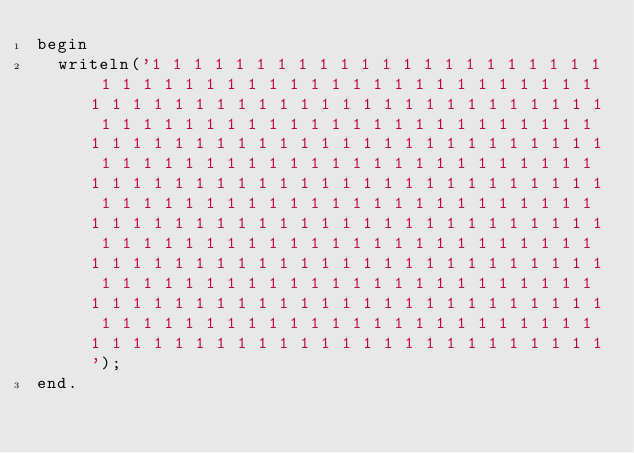<code> <loc_0><loc_0><loc_500><loc_500><_Pascal_>begin
	writeln('1 1 1 1 1 1 1 1 1 1 1 1 1 1 1 1 1 1 1 1 1 1 1 1 1 1 1 1 1 1 1 1 1 1 1 1 1 1 1 1 1 1 1 1 1 1 1 1 1 1 1 1 1 1 1 1 1 1 1 1 1 1 1 1 1 1 1 1 1 1 1 1 1 1 1 1 1 1 1 1 1 1 1 1 1 1 1 1 1 1 1 1 1 1 1 1 1 1 1 1 1 1 1 1 1 1 1 1 1 1 1 1 1 1 1 1 1 1 1 1 1 1 1 1 1 1 1 1 1 1 1 1 1 1 1 1 1 1 1 1 1 1 1 1 1 1 1 1 1 1 1 1 1 1 1 1 1 1 1 1 1 1 1 1 1 1 1 1 1 1 1 1 1 1 1 1 1 1 1 1 1 1 1 1 1 1 1 1 1 1 1 1 1 1 1 1 1 1 1 1 1 1 1 1 1 1 1 1 1 1 1 1 1 1 1 1 1 1 1 1 1 1 1 1 1 1 1 1 1 1 1 1 1 1 1 1 1 1 1 1 1 1 1 1 1 1 1 1 1 1 1 1 1 1 1 1 1 1 1 1 1 1 1 1 1 1 1 1 1 1 1 1 1 1 1 1 1 1 1 1 1 1 1 1 1 1 1 1 1 1 1 1 1 1 1 1 1 1 1 1 1 1 1 1 1 1 1 1 1 1 1 1 1 1 1 1 1 1 1 1 1 1 1 1 1 1 1 1 1 1 1 1 1 1 1 1 1 1 1 1 1 1 1 1 1 1 1 1 1 1 1 1 1 1 1 1 1 1 1 1 1 1 1 1 1');
end.
</code> 